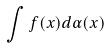<formula> <loc_0><loc_0><loc_500><loc_500>\int f ( x ) d \alpha ( x )</formula> 